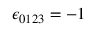<formula> <loc_0><loc_0><loc_500><loc_500>\epsilon _ { 0 1 2 3 } = - 1</formula> 